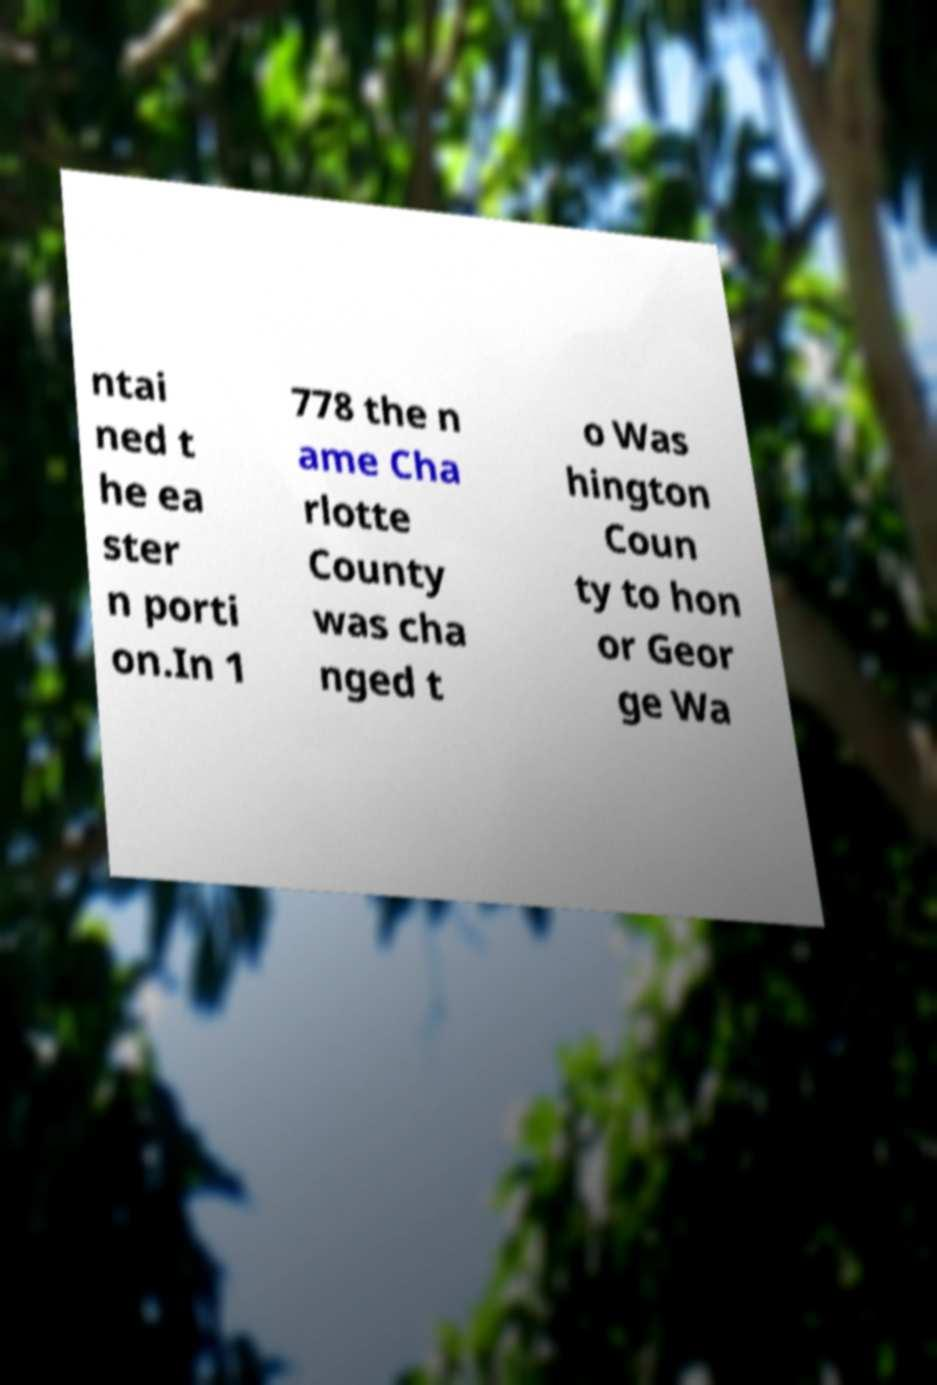Please identify and transcribe the text found in this image. ntai ned t he ea ster n porti on.In 1 778 the n ame Cha rlotte County was cha nged t o Was hington Coun ty to hon or Geor ge Wa 